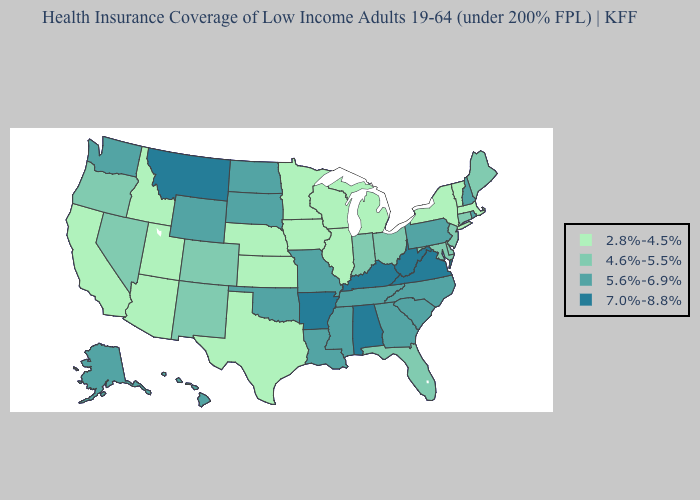Does the map have missing data?
Short answer required. No. Does Kentucky have the highest value in the South?
Give a very brief answer. Yes. Among the states that border Montana , does Idaho have the highest value?
Write a very short answer. No. Which states hav the highest value in the West?
Give a very brief answer. Montana. How many symbols are there in the legend?
Answer briefly. 4. What is the highest value in states that border West Virginia?
Answer briefly. 7.0%-8.8%. What is the lowest value in the USA?
Short answer required. 2.8%-4.5%. What is the highest value in the West ?
Quick response, please. 7.0%-8.8%. What is the lowest value in the MidWest?
Be succinct. 2.8%-4.5%. What is the value of Oklahoma?
Short answer required. 5.6%-6.9%. What is the value of Montana?
Short answer required. 7.0%-8.8%. Does New Jersey have the same value as Florida?
Short answer required. Yes. Does Nebraska have the same value as Indiana?
Be succinct. No. What is the value of New Hampshire?
Answer briefly. 5.6%-6.9%. 